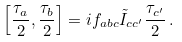<formula> <loc_0><loc_0><loc_500><loc_500>\left [ \frac { { \tau } _ { a } } 2 , \frac { { \tau } _ { b } } 2 \right ] = i { f } _ { a b c } \tilde { I } _ { c c ^ { \prime } } \frac { \tau _ { c ^ { \prime } } } 2 \, .</formula> 